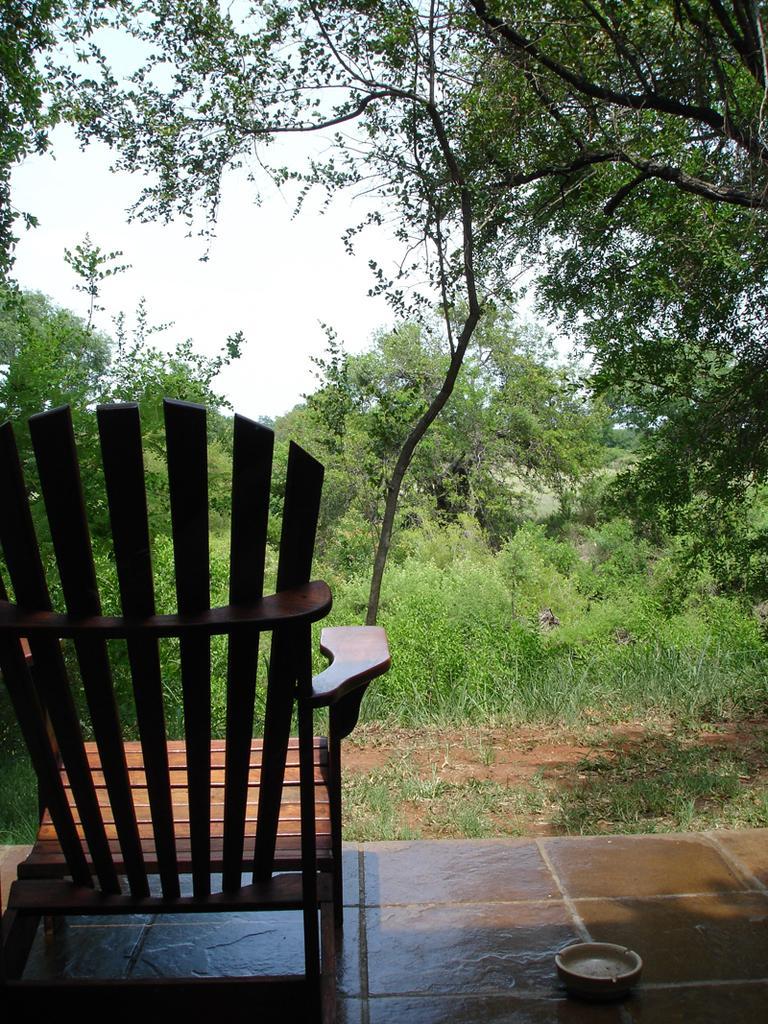Please provide a concise description of this image. In this picture I can see a chair, there is grass, there are plants, trees, and in the background there is the sky. 